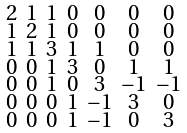Convert formula to latex. <formula><loc_0><loc_0><loc_500><loc_500>\begin{smallmatrix} 2 & 1 & 1 & 0 & 0 & 0 & 0 \\ 1 & 2 & 1 & 0 & 0 & 0 & 0 \\ 1 & 1 & 3 & 1 & 1 & 0 & 0 \\ 0 & 0 & 1 & 3 & 0 & 1 & 1 \\ 0 & 0 & 1 & 0 & 3 & - 1 & - 1 \\ 0 & 0 & 0 & 1 & - 1 & 3 & 0 \\ 0 & 0 & 0 & 1 & - 1 & 0 & 3 \end{smallmatrix}</formula> 